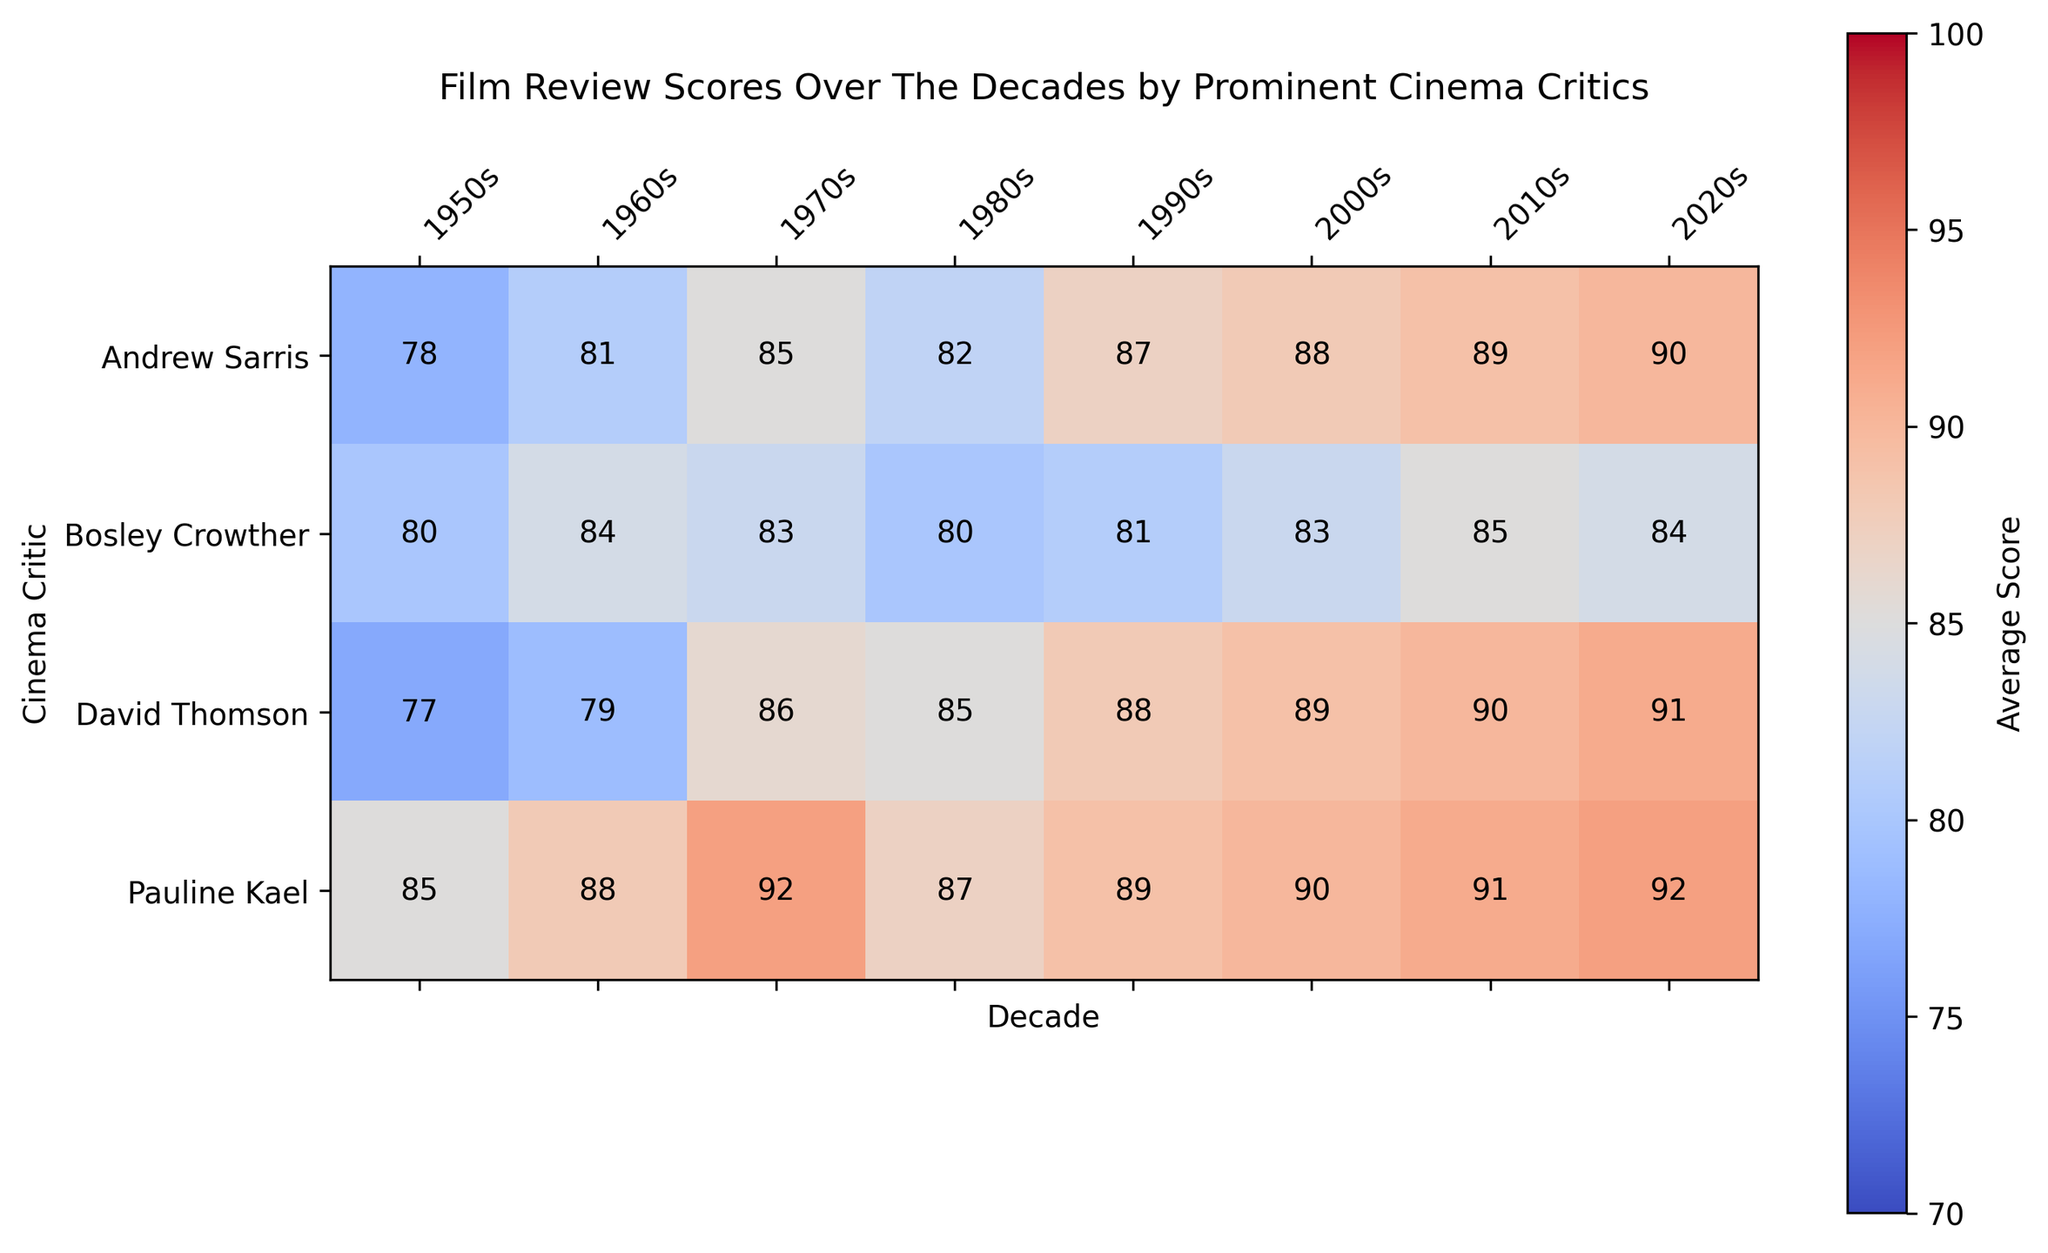What is the highest film review score given by Pauline Kael in any decade? To find the highest score given by Pauline Kael, we examine the values in the row corresponding to her and identify the highest number.
Answer: 92 Which decade has the lowest average score given by Bosley Crowther? To determine the lowest score given by Bosley Crowther, we check the values in his row and find the minimum.
Answer: 1950s Who gave the highest average score in the 2010s? To identify the highest average score in the 2010s, we scan the column for the 2010s and find the critic with the highest value.
Answer: David Thomson What is the difference in the average scores between the 1950s and 2020s for Pauline Kael? To calculate the difference, we subtract Pauline Kael's score in the 1950s from her score in the 2020s (92 - 85).
Answer: 7 Which critic has shown the most consistent scoring pattern across the decades? Consistency can be gauged by the smallest range in scores (maximum score - minimum score) for each critic. Analyzing all critics, Bosley Crowther has the smallest range (85 - 80 = 5).
Answer: Bosley Crowther How many scores of 90 or above were given by critics in the 2020s? To answer this, we count the number of scores 90 or above in the 2020s column. There are three counts (92, 90, 91).
Answer: 3 Who increased their average score the most from the 1980s to the 1990s? To find this, we calculate the difference in scores from the 1980s to the 1990s for each critic and identify the largest increase. David Thomson had the largest increase (88 - 85 = 3).
Answer: David Thomson In which decade did Andrew Sarris give his lowest average score? We check the values in Andrew Sarris' row and identify the smallest value.
Answer: 1950s What visual trend is noticeable in the heatmap for Pauline Kael? Visually, the color intensity becomes slightly stronger towards the latter decades, indicating increasing scores.
Answer: Increasing trend How does David Thomson’s average score in the 1970s compare to his score in the 2000s? We compare the two scores in David Thomson's row for the 1970s and 2000s (86 and 89 respectively). The 2000s score is higher.
Answer: Higher in 2000s 